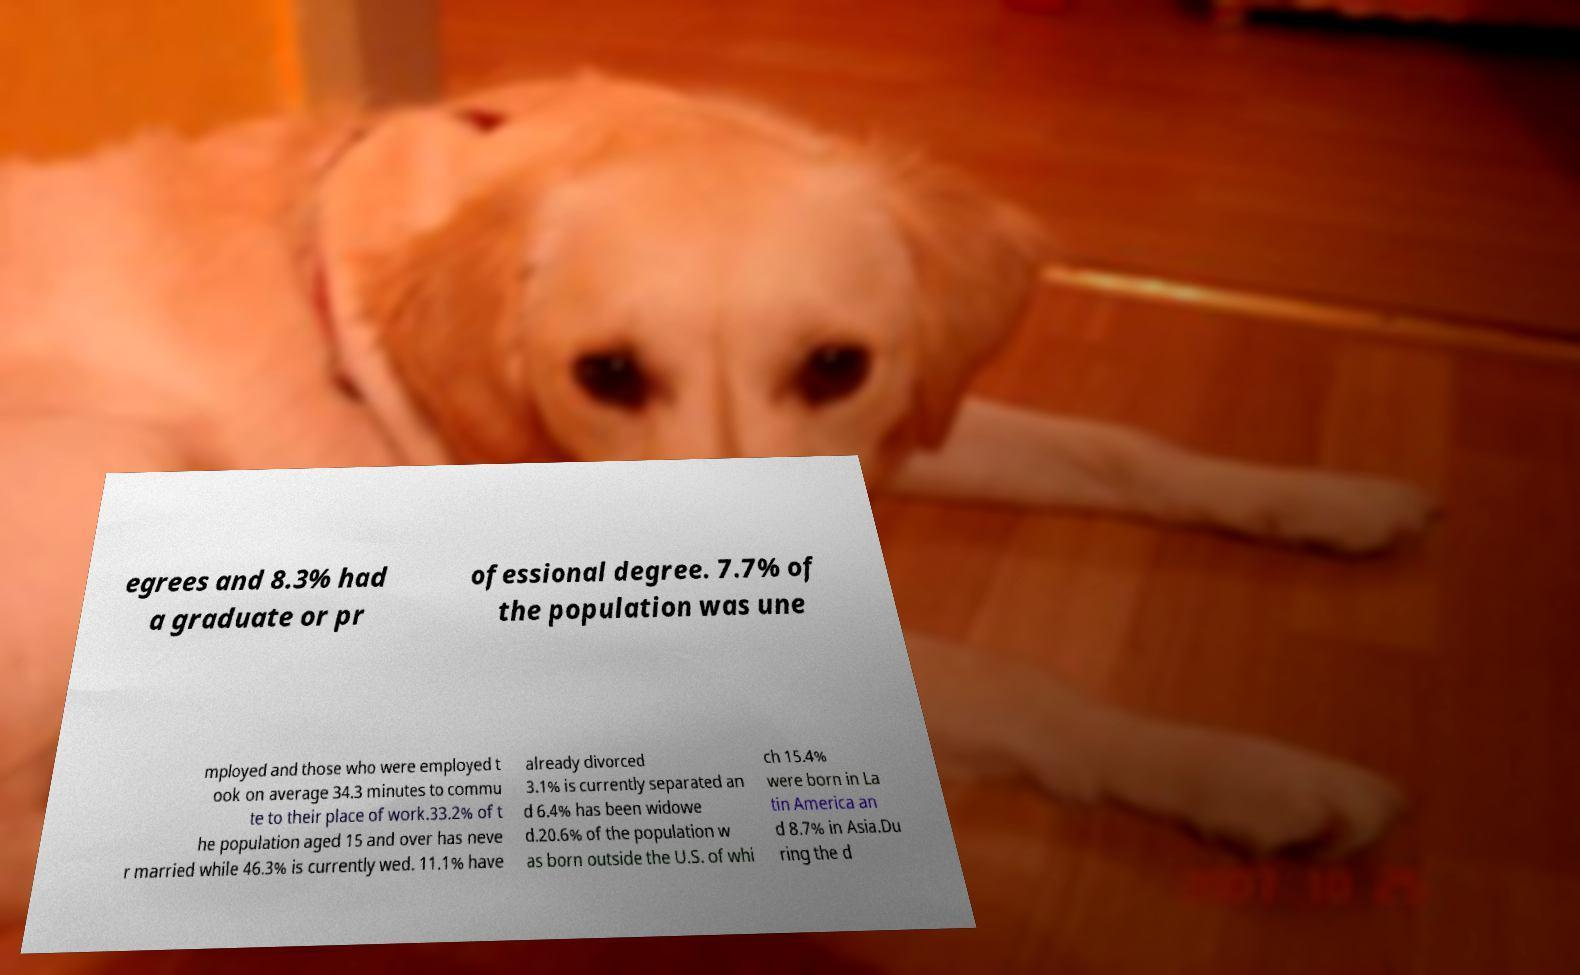Please read and relay the text visible in this image. What does it say? egrees and 8.3% had a graduate or pr ofessional degree. 7.7% of the population was une mployed and those who were employed t ook on average 34.3 minutes to commu te to their place of work.33.2% of t he population aged 15 and over has neve r married while 46.3% is currently wed. 11.1% have already divorced 3.1% is currently separated an d 6.4% has been widowe d.20.6% of the population w as born outside the U.S. of whi ch 15.4% were born in La tin America an d 8.7% in Asia.Du ring the d 